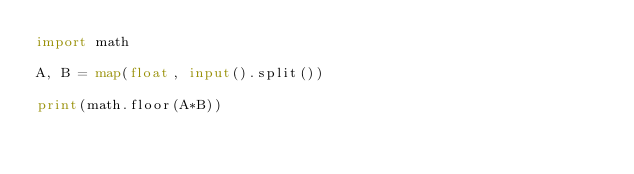<code> <loc_0><loc_0><loc_500><loc_500><_Python_>import math

A, B = map(float, input().split())

print(math.floor(A*B))</code> 